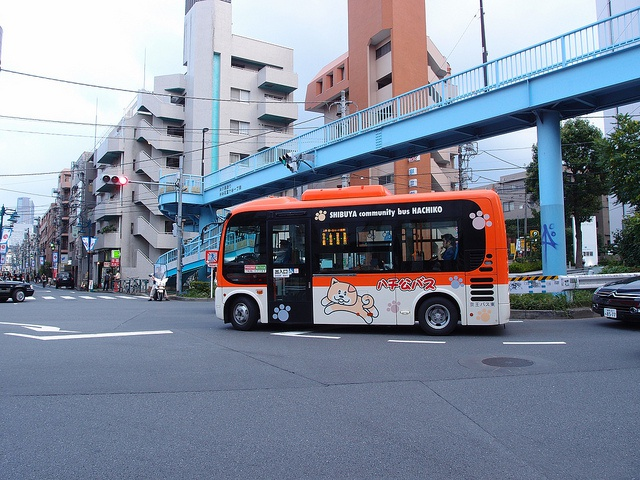Describe the objects in this image and their specific colors. I can see bus in white, black, darkgray, and red tones, car in white, black, navy, darkgray, and gray tones, car in white, black, gray, and darkgray tones, traffic light in white, black, lavender, darkgray, and maroon tones, and people in white, black, gray, and navy tones in this image. 